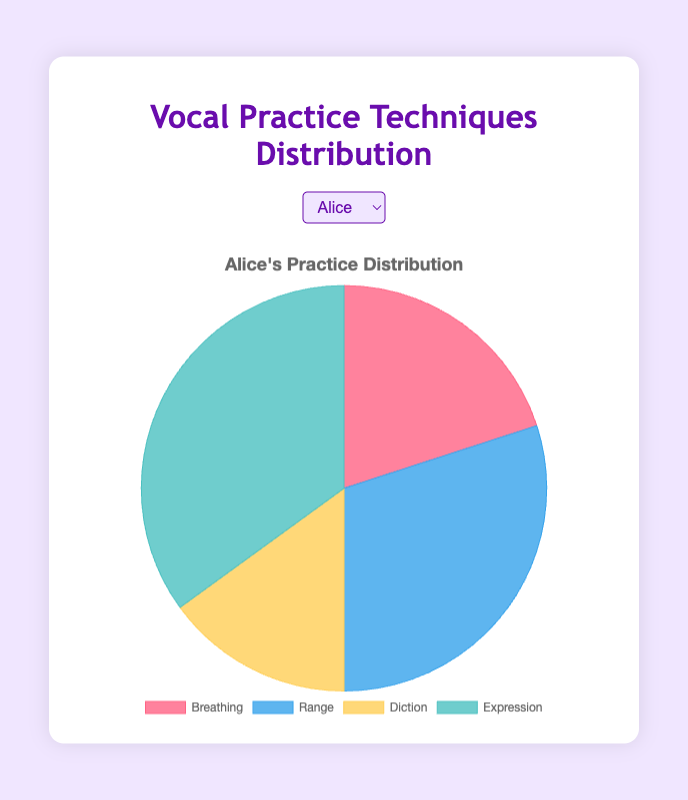Which vocal technique does Alice spend the most time practicing? Look at Alice's chart and find the segment with the largest area. The largest portion is for Expression at 35%.
Answer: Expression Comparing Breathing and Range, which one does Bob spend more time practicing? Look at Bob's chart and compare the sizes of the segments for Breathing and Range. Both segments are equal at 25% each.
Answer: Equal What is the combined time percentage Eve spends on Breathing and Diction? Look at Eve's chart, add the percentages for Breathing and Diction: 20% (Breathing) + 10% (Diction) = 30%.
Answer: 30% How does Carol's focus on Range compare to David's focus on Range? Look at the charts for Carol and David. Carol spends 20% on Range, while David spends 35%.
Answer: David spends more If you sum Alice's time spent on Breathing, Diction, and Expression, what do you get? Look at Alice's chart and sum the percentages: 20% (Breathing) + 15% (Diction) + 35% (Expression) = 70%.
Answer: 70% Which student has the most balanced distribution of practice time across the four techniques? Check all charts for the most equal distribution. Bob's chart shows all segments equal at 25% each.
Answer: Bob What's the difference in percentage of time spent on Breathing between Carol and David? Look at Carol's and David's charts. Carol spends 30% on Breathing, and David spends 15%. The difference is 30% - 15% = 15%.
Answer: 15% Which technique does Eve spend the least time practicing? Look at Eve's chart and find the smallest segment. The smallest portion is Diction at 10%.
Answer: Diction What is the average percentage of time Alice and Bob spend on Expression? Find the Expression percentages for Alice (35%) and Bob (25%), then calculate the average: (35% + 25%) / 2 = 30%.
Answer: 30% Does any student spend exactly 25% of their practice time on all four techniques? Look through the charts of all students. Bob is the only one with all four techniques at 25%.
Answer: Yes 